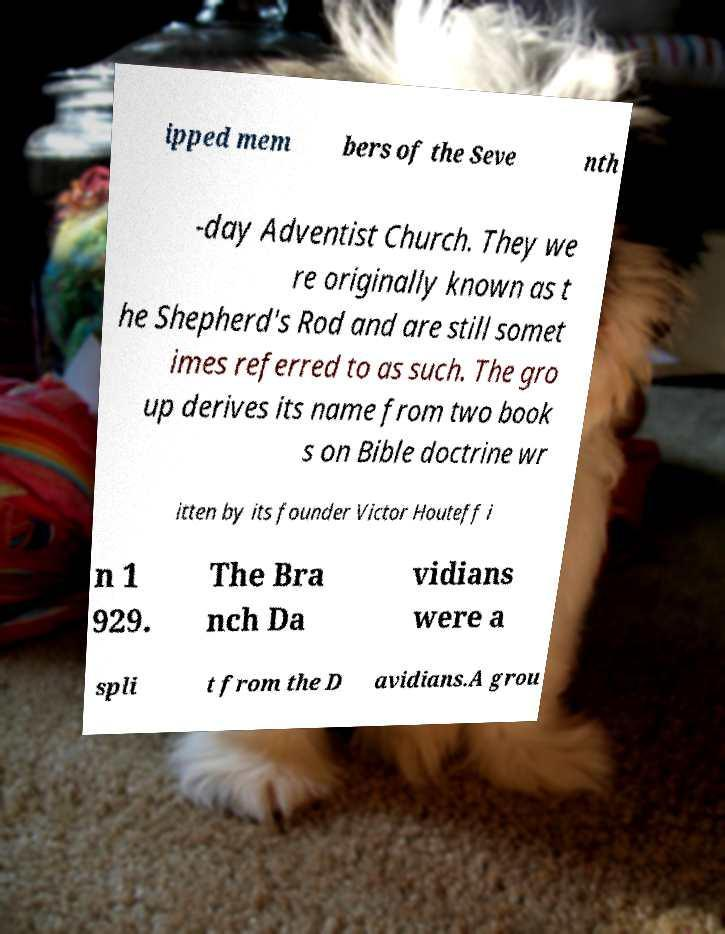Can you read and provide the text displayed in the image?This photo seems to have some interesting text. Can you extract and type it out for me? ipped mem bers of the Seve nth -day Adventist Church. They we re originally known as t he Shepherd's Rod and are still somet imes referred to as such. The gro up derives its name from two book s on Bible doctrine wr itten by its founder Victor Houteff i n 1 929. The Bra nch Da vidians were a spli t from the D avidians.A grou 